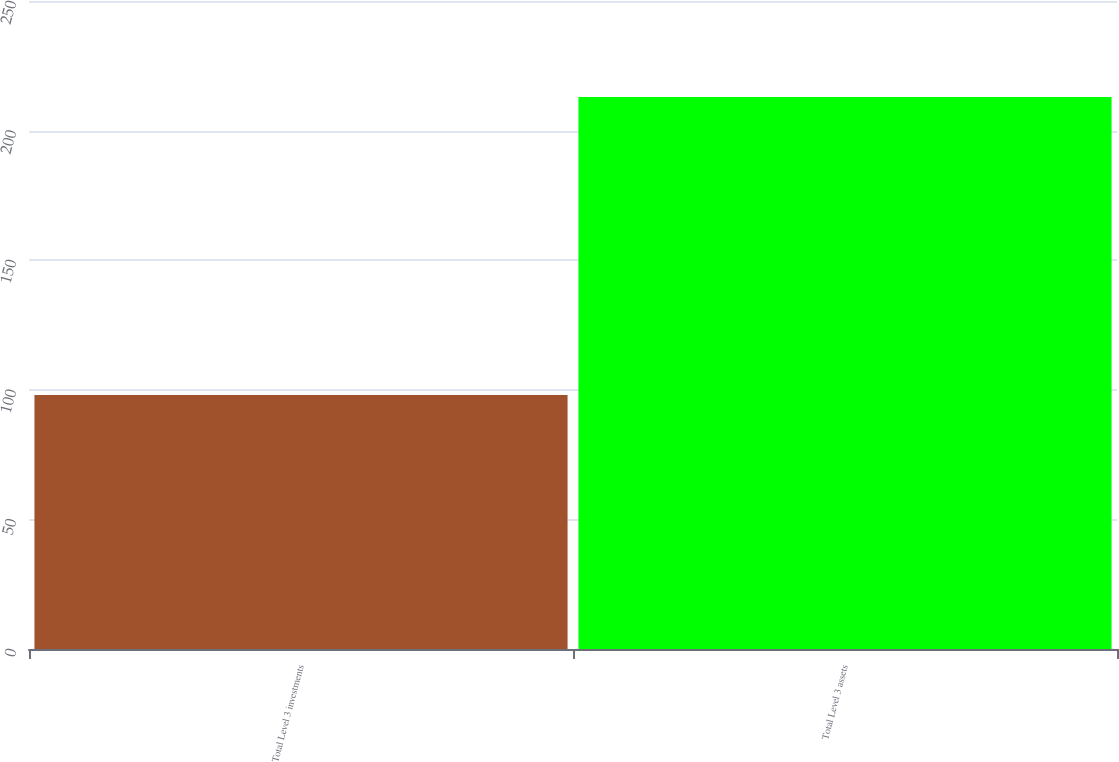Convert chart. <chart><loc_0><loc_0><loc_500><loc_500><bar_chart><fcel>Total Level 3 investments<fcel>Total Level 3 assets<nl><fcel>98<fcel>213<nl></chart> 